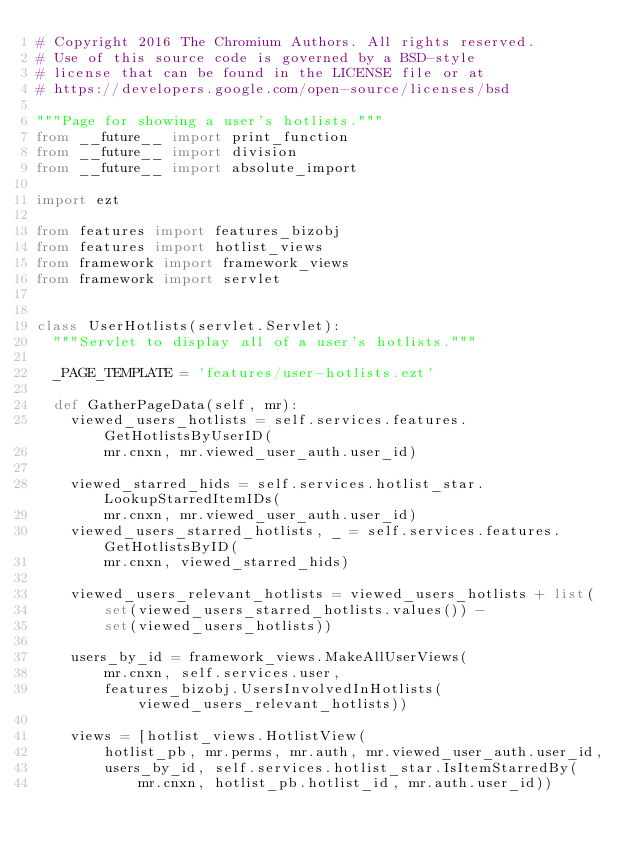<code> <loc_0><loc_0><loc_500><loc_500><_Python_># Copyright 2016 The Chromium Authors. All rights reserved.
# Use of this source code is governed by a BSD-style
# license that can be found in the LICENSE file or at
# https://developers.google.com/open-source/licenses/bsd

"""Page for showing a user's hotlists."""
from __future__ import print_function
from __future__ import division
from __future__ import absolute_import

import ezt

from features import features_bizobj
from features import hotlist_views
from framework import framework_views
from framework import servlet


class UserHotlists(servlet.Servlet):
  """Servlet to display all of a user's hotlists."""

  _PAGE_TEMPLATE = 'features/user-hotlists.ezt'

  def GatherPageData(self, mr):
    viewed_users_hotlists = self.services.features.GetHotlistsByUserID(
        mr.cnxn, mr.viewed_user_auth.user_id)

    viewed_starred_hids = self.services.hotlist_star.LookupStarredItemIDs(
        mr.cnxn, mr.viewed_user_auth.user_id)
    viewed_users_starred_hotlists, _ = self.services.features.GetHotlistsByID(
        mr.cnxn, viewed_starred_hids)

    viewed_users_relevant_hotlists = viewed_users_hotlists + list(
        set(viewed_users_starred_hotlists.values()) -
        set(viewed_users_hotlists))

    users_by_id = framework_views.MakeAllUserViews(
        mr.cnxn, self.services.user,
        features_bizobj.UsersInvolvedInHotlists(viewed_users_relevant_hotlists))

    views = [hotlist_views.HotlistView(
        hotlist_pb, mr.perms, mr.auth, mr.viewed_user_auth.user_id,
        users_by_id, self.services.hotlist_star.IsItemStarredBy(
            mr.cnxn, hotlist_pb.hotlist_id, mr.auth.user_id))</code> 